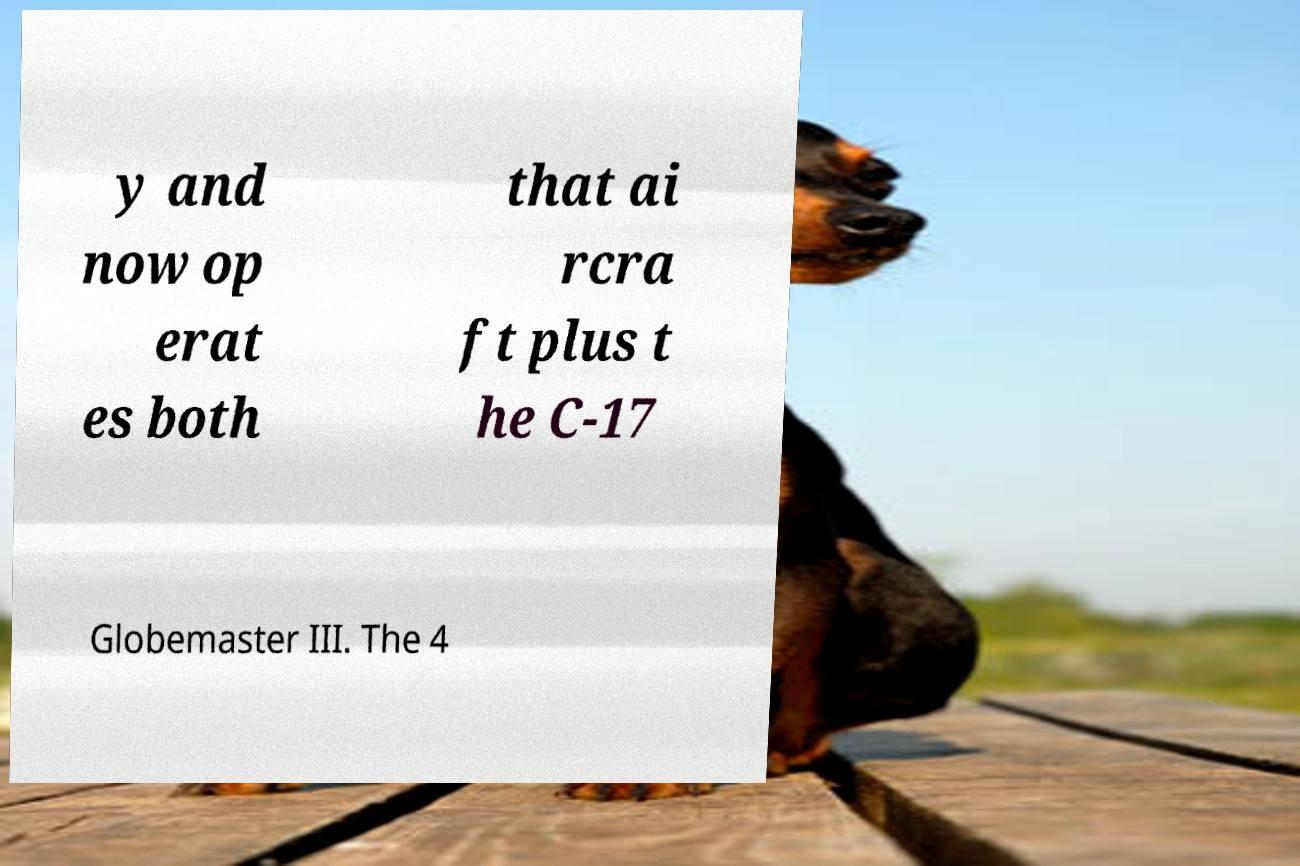Please read and relay the text visible in this image. What does it say? y and now op erat es both that ai rcra ft plus t he C-17 Globemaster III. The 4 